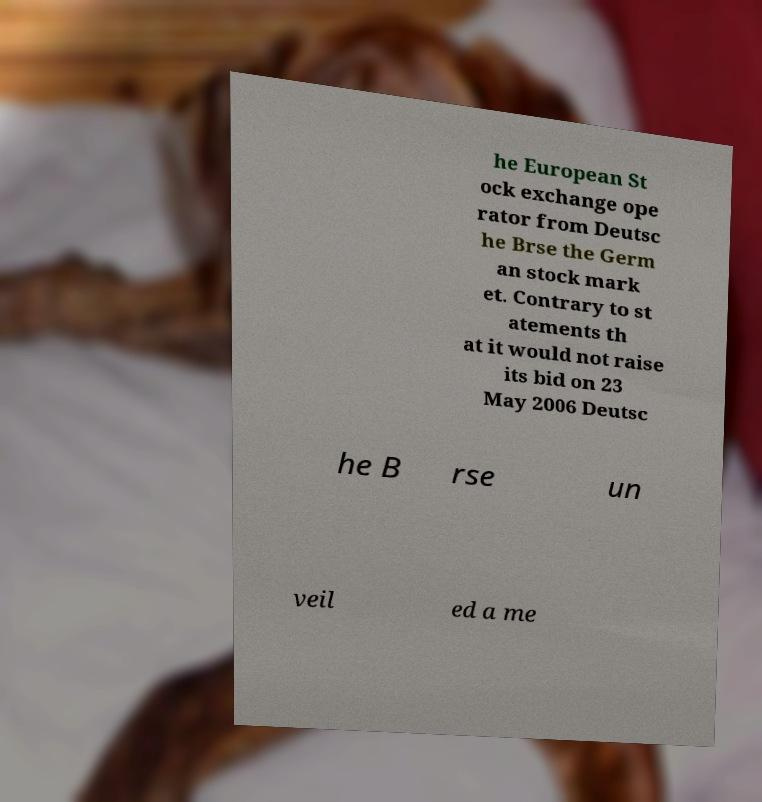Please read and relay the text visible in this image. What does it say? he European St ock exchange ope rator from Deutsc he Brse the Germ an stock mark et. Contrary to st atements th at it would not raise its bid on 23 May 2006 Deutsc he B rse un veil ed a me 